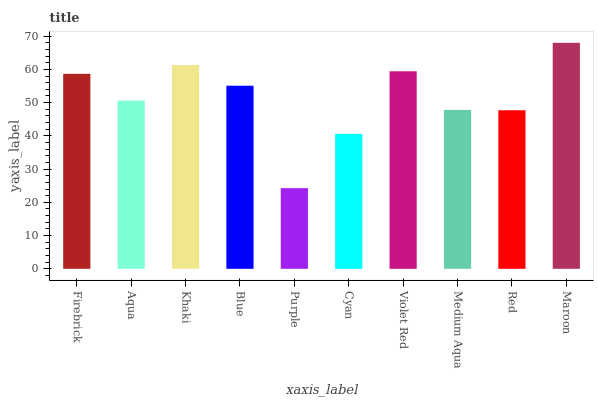Is Purple the minimum?
Answer yes or no. Yes. Is Maroon the maximum?
Answer yes or no. Yes. Is Aqua the minimum?
Answer yes or no. No. Is Aqua the maximum?
Answer yes or no. No. Is Firebrick greater than Aqua?
Answer yes or no. Yes. Is Aqua less than Firebrick?
Answer yes or no. Yes. Is Aqua greater than Firebrick?
Answer yes or no. No. Is Firebrick less than Aqua?
Answer yes or no. No. Is Blue the high median?
Answer yes or no. Yes. Is Aqua the low median?
Answer yes or no. Yes. Is Aqua the high median?
Answer yes or no. No. Is Red the low median?
Answer yes or no. No. 